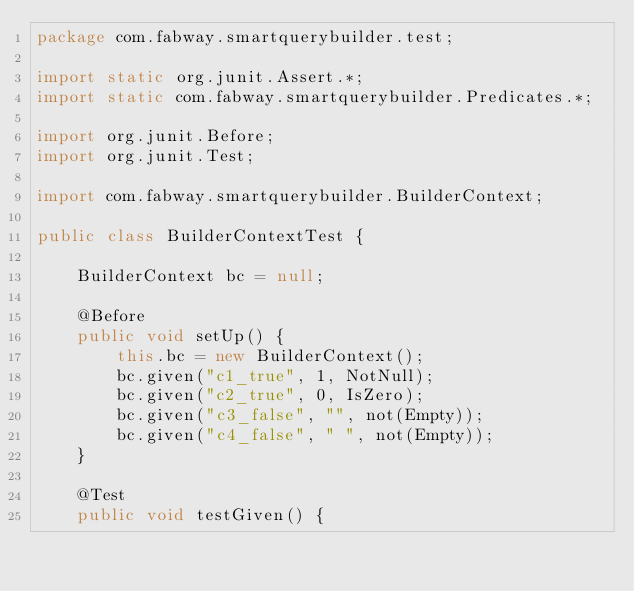Convert code to text. <code><loc_0><loc_0><loc_500><loc_500><_Java_>package com.fabway.smartquerybuilder.test;

import static org.junit.Assert.*;
import static com.fabway.smartquerybuilder.Predicates.*;

import org.junit.Before;
import org.junit.Test;

import com.fabway.smartquerybuilder.BuilderContext;

public class BuilderContextTest {

	BuilderContext bc = null;

	@Before
	public void setUp() {
		this.bc = new BuilderContext();
		bc.given("c1_true", 1, NotNull);
		bc.given("c2_true", 0, IsZero);
		bc.given("c3_false", "", not(Empty));
		bc.given("c4_false", " ", not(Empty));
	}

	@Test
	public void testGiven() {</code> 